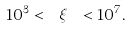Convert formula to latex. <formula><loc_0><loc_0><loc_500><loc_500>1 0 ^ { 3 } < \ \xi \ < 1 0 ^ { 7 } .</formula> 